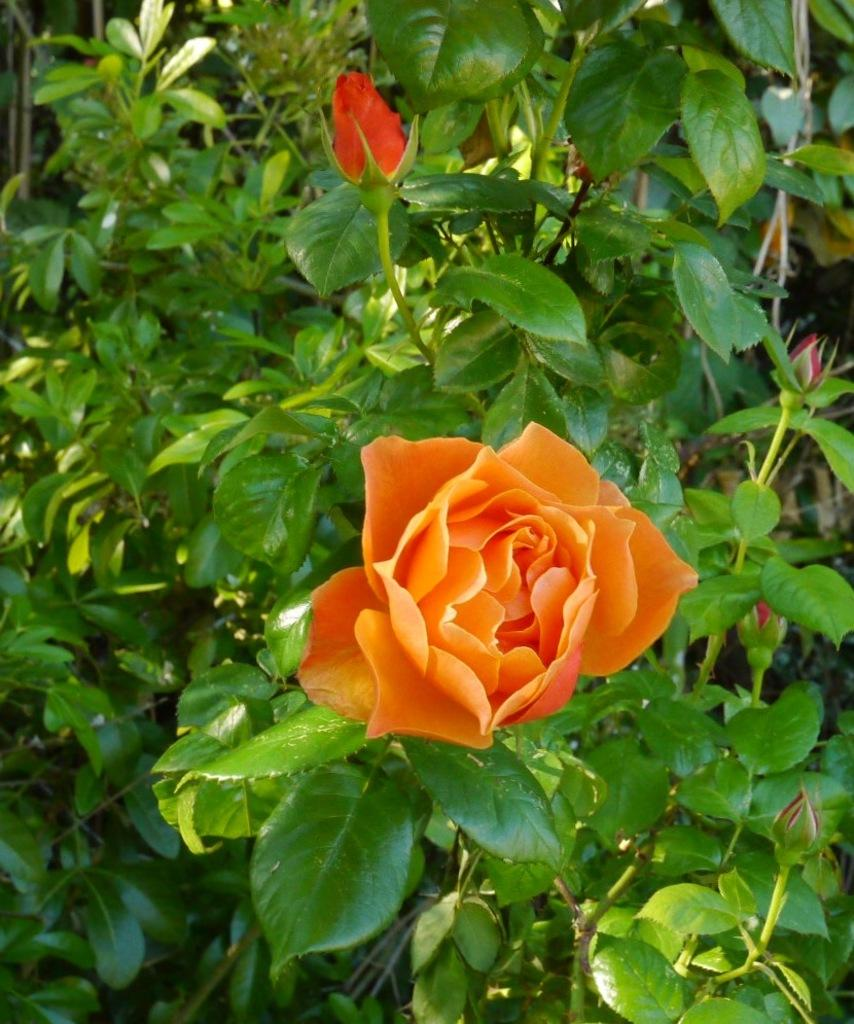What is the main subject of the image? The main subject of the image is a plant. Can you describe the plant in more detail? Yes, there is a red rose in the middle of the image. What question is being asked by the red rose in the image? There is no indication in the image that the red rose is asking a question. 